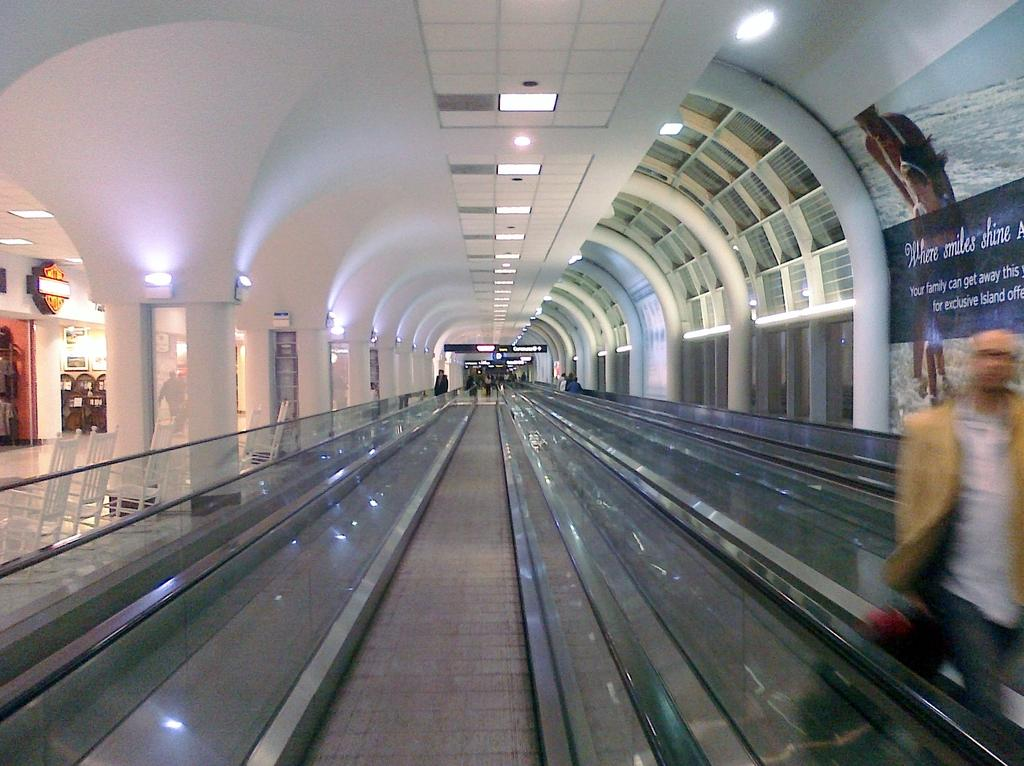<image>
Give a short and clear explanation of the subsequent image. An airport hallway with a banner that says "Where smiles shine". 